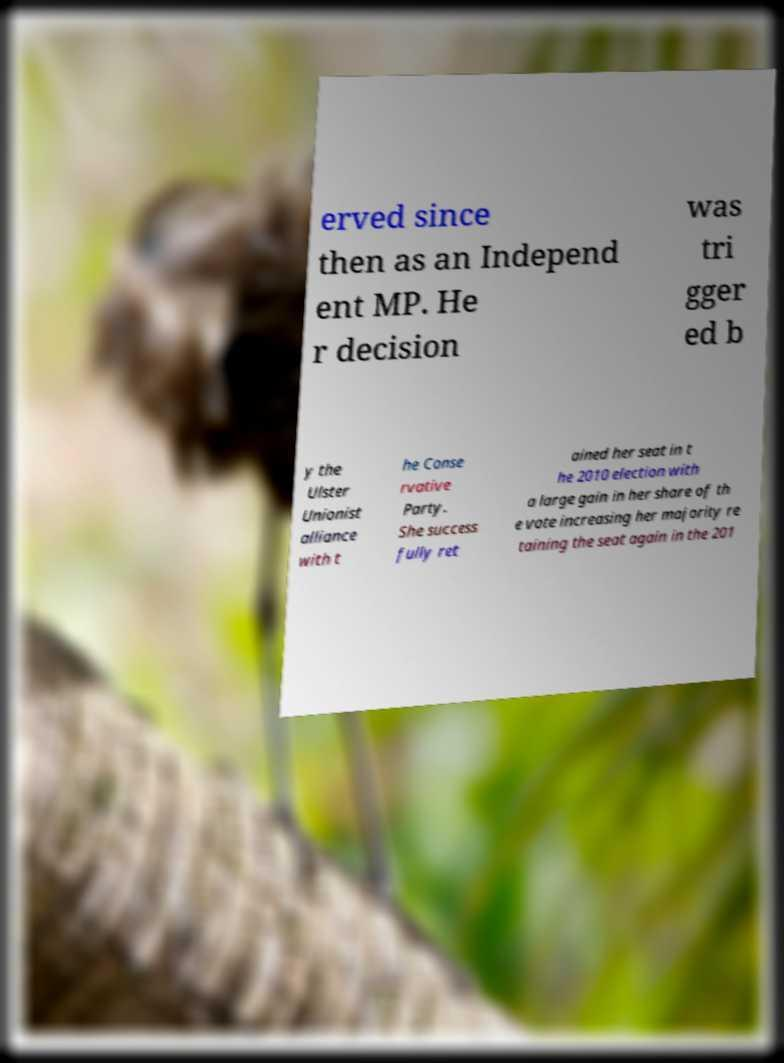Please identify and transcribe the text found in this image. erved since then as an Independ ent MP. He r decision was tri gger ed b y the Ulster Unionist alliance with t he Conse rvative Party. She success fully ret ained her seat in t he 2010 election with a large gain in her share of th e vote increasing her majority re taining the seat again in the 201 